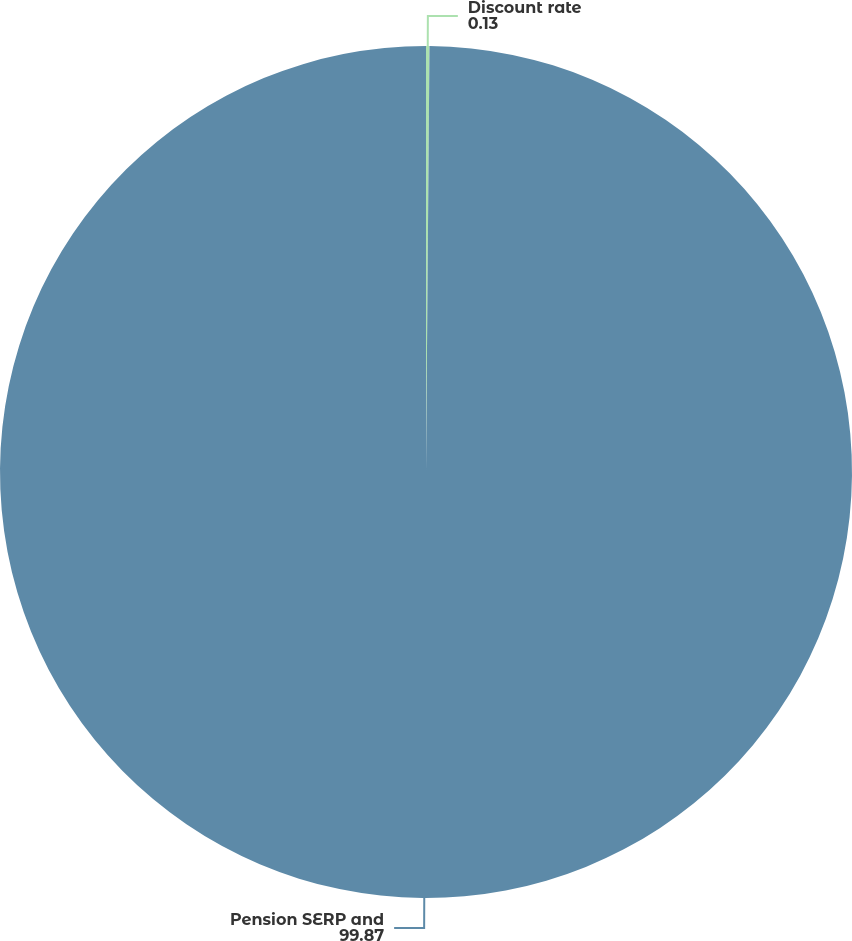Convert chart to OTSL. <chart><loc_0><loc_0><loc_500><loc_500><pie_chart><fcel>Discount rate<fcel>Pension SERP and<nl><fcel>0.13%<fcel>99.87%<nl></chart> 